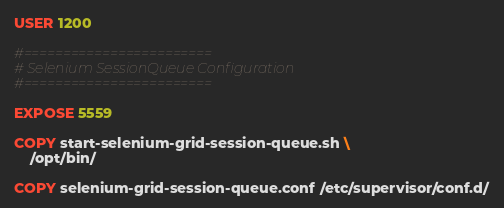Convert code to text. <code><loc_0><loc_0><loc_500><loc_500><_Dockerfile_>USER 1200

#========================
# Selenium SessionQueue Configuration
#========================

EXPOSE 5559

COPY start-selenium-grid-session-queue.sh \
    /opt/bin/

COPY selenium-grid-session-queue.conf /etc/supervisor/conf.d/
</code> 